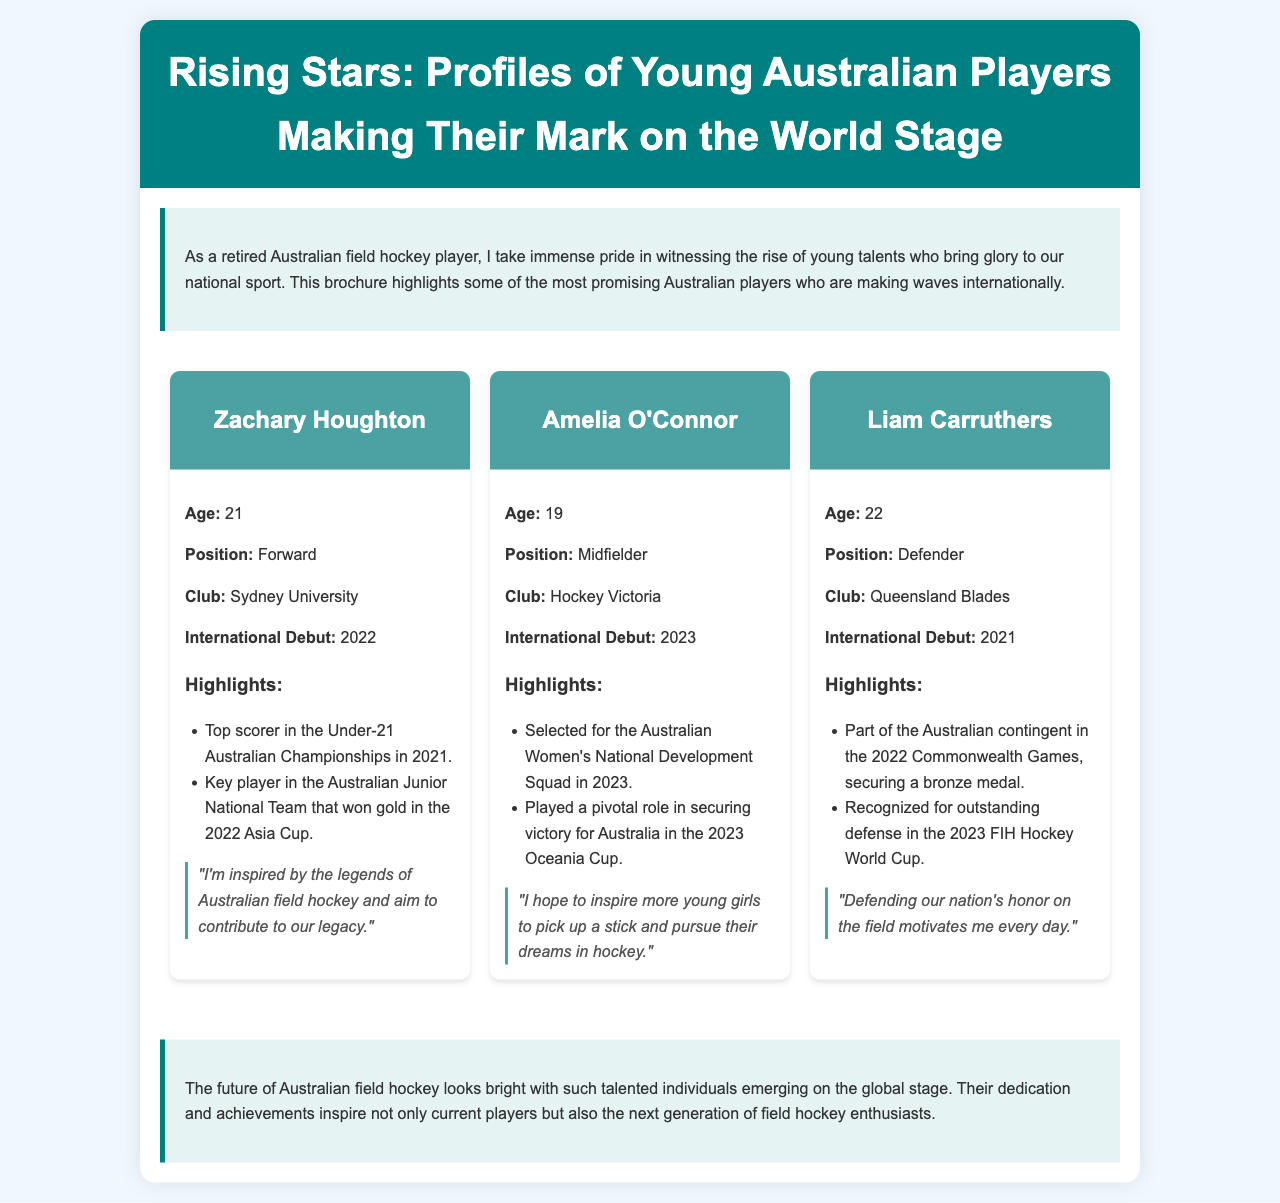what is the age of Zachary Houghton? The age of Zachary Houghton is directly stated in his profile as 21.
Answer: 21 who played a pivotal role in securing victory for Australia in 2023? The document mentions Amelia O'Connor as having played a pivotal role in the victory in the 2023 Oceania Cup.
Answer: Amelia O'Connor how many players are profiled in this brochure? The brochure features profiles for three young players, as listed in the document.
Answer: Three what position does Liam Carruthers play? This information is available in Liam Carruthers's profile, where it states he plays as a Defender.
Answer: Defender when did Amelia O'Connor make her international debut? Amelia O'Connor's international debut year is specified as 2023 in her profile.
Answer: 2023 what quote is attributed to Zachary Houghton? The quote for Zachary Houghton is included in his profile and can be found exactly as stated.
Answer: "I'm inspired by the legends of Australian field hockey and aim to contribute to our legacy." which club does Zachary Houghton belong to? The document lists Sydney University as Zachary Houghton’s club in his profile.
Answer: Sydney University what achievement is highlighted for Liam Carruthers at the 2023 FIH Hockey World Cup? Liam Carruthers is recognized for his outstanding defense in the 2023 FIH Hockey World Cup as noted in his profile.
Answer: Outstanding defense 